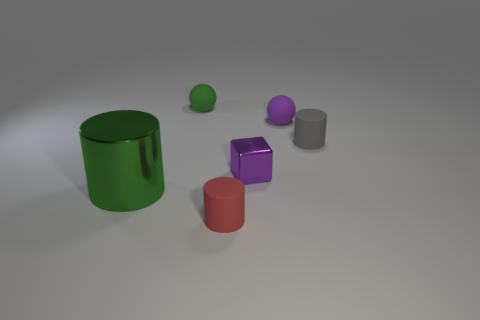The matte thing that is the same color as the small metallic object is what size?
Offer a very short reply. Small. There is a metal object on the left side of the small red rubber object; what is its color?
Your answer should be very brief. Green. There is a purple metallic object; does it have the same shape as the object that is in front of the large object?
Ensure brevity in your answer.  No. Are there any rubber things of the same color as the block?
Provide a short and direct response. Yes. There is a thing that is made of the same material as the large green cylinder; what is its size?
Give a very brief answer. Small. Does the small shiny object have the same color as the big shiny thing?
Offer a very short reply. No. Is the shape of the small purple thing in front of the gray object the same as  the red object?
Provide a short and direct response. No. How many red matte cylinders are the same size as the purple cube?
Offer a terse response. 1. What shape is the small thing that is the same color as the metal cube?
Offer a terse response. Sphere. There is a cylinder that is to the left of the red matte thing; are there any blocks on the left side of it?
Offer a terse response. No. 